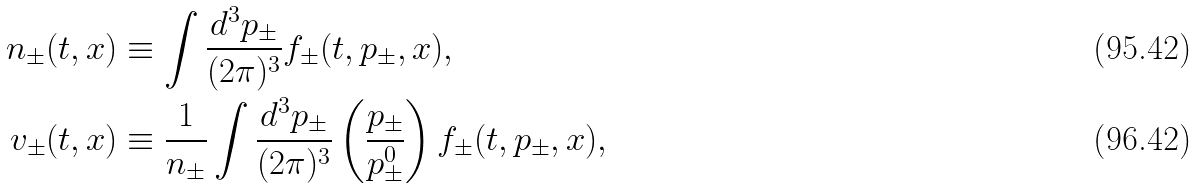Convert formula to latex. <formula><loc_0><loc_0><loc_500><loc_500>n _ { \pm } ( t , { x } ) & \equiv \int \frac { d ^ { 3 } { p } _ { \pm } } { ( 2 \pi ) ^ { 3 } } f _ { \pm } ( t , { p } _ { \pm } , { x } ) , \\ { v } _ { \pm } ( t , { x } ) & \equiv \frac { 1 } { n _ { \pm } } \int \frac { d ^ { 3 } { p } _ { \pm } } { ( 2 \pi ) ^ { 3 } } \left ( \frac { { p } _ { \pm } } { p ^ { 0 } _ { \pm } } \right ) f _ { \pm } ( t , { p } _ { \pm } , { x } ) ,</formula> 